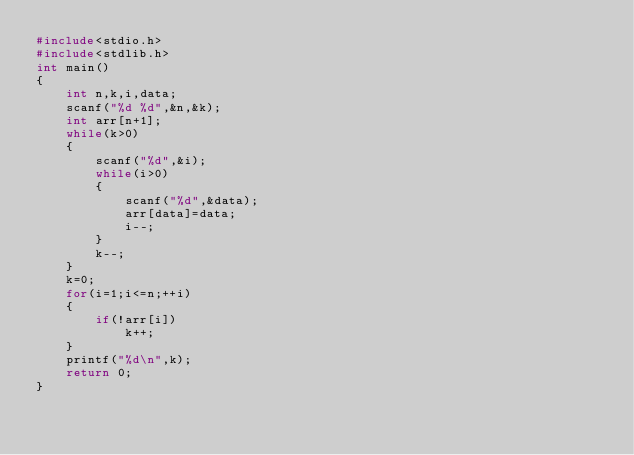<code> <loc_0><loc_0><loc_500><loc_500><_C_>#include<stdio.h>
#include<stdlib.h>
int main()
{
	int n,k,i,data;
	scanf("%d %d",&n,&k);
	int arr[n+1];
	while(k>0)
	{
		scanf("%d",&i);
		while(i>0)
		{
			scanf("%d",&data);
			arr[data]=data;
			i--;
		}
		k--;
	}
	k=0;
	for(i=1;i<=n;++i)
	{
		if(!arr[i])
			k++;
	}
	printf("%d\n",k);
	return 0;
}
	
</code> 